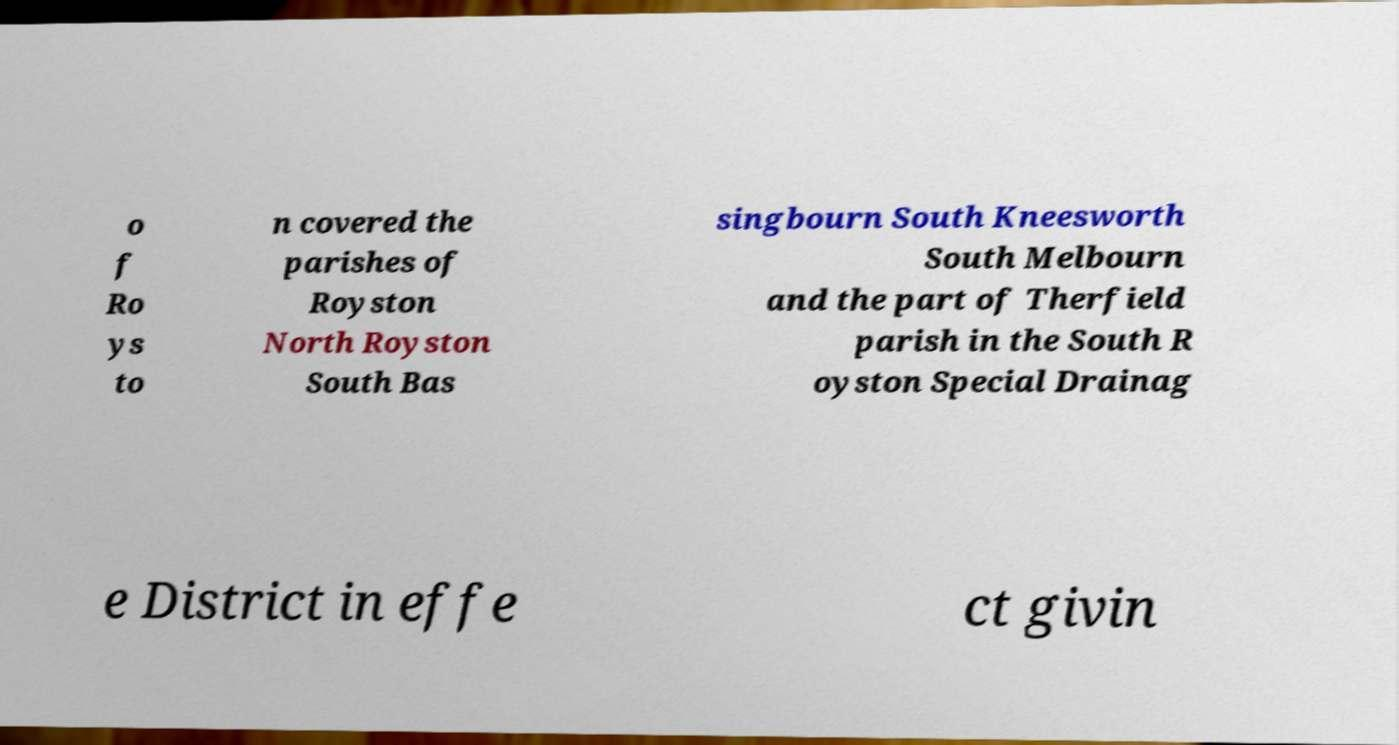What messages or text are displayed in this image? I need them in a readable, typed format. o f Ro ys to n covered the parishes of Royston North Royston South Bas singbourn South Kneesworth South Melbourn and the part of Therfield parish in the South R oyston Special Drainag e District in effe ct givin 